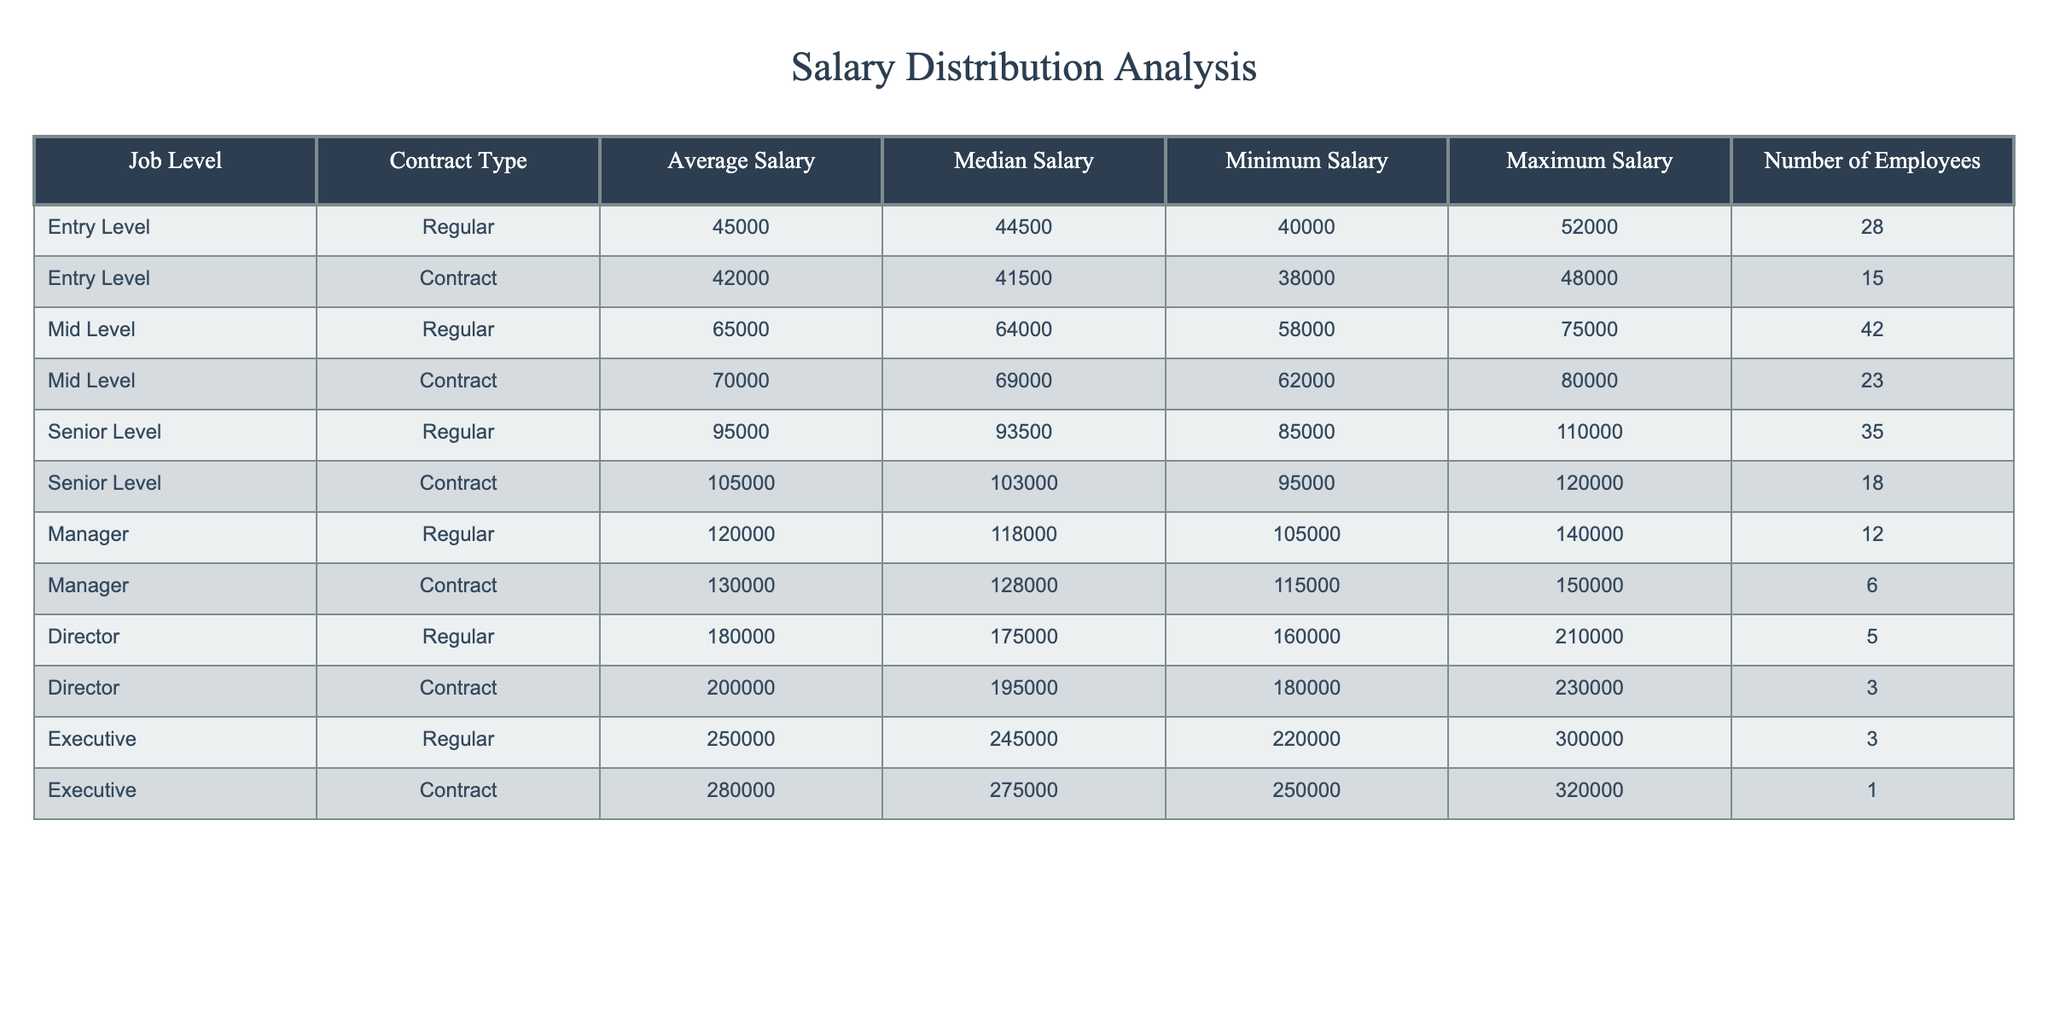What is the average salary for Senior Level Regular employees? The average salary for Senior Level Regular employees is listed in the table under the "Average Salary" column for that job level. It states 95000.
Answer: 95000 What is the median salary for Mid Level Contract workers? The median salary for Mid Level Contract workers can be found in the "Median Salary" column specifically for the Mid Level and Contract type, which is 69000.
Answer: 69000 Which job level has the highest minimum salary among Regular employees? By looking at the "Minimum Salary" column for Regular employees, we can see the minimum salaries are 40000 (Entry Level), 58000 (Mid Level), 85000 (Senior Level), 105000 (Manager), 160000 (Director), and 220000 (Executive). The highest minimum salary is 160000 for Director level.
Answer: 160000 Is the average salary for Contract workers generally higher than for Regular employees at the Mid Level? Comparing the average salaries for Mid Level Regular (65000) and Mid Level Contract (70000), the average salary for Mid Level Contract workers is indeed higher (70000 > 65000).
Answer: Yes What is the difference between the maximum salaries of Entry Level Regular and Contract employees? The maximum salary for Entry Level Regular employees is 52000 and for Entry Level Contract employees is 48000. The difference is calculated by subtracting the maximum of Contract from Regular: 52000 - 48000 = 4000.
Answer: 4000 At which job level and contract type do we see the largest salary range? To find this, we calculate the range (Maximum - Minimum) for each job level. For Contract employees: Entry (48000-38000=10000), Mid (80000-62000=18000), Senior (120000-95000=25000), Manager (150000-115000=35000), Director (230000-180000=50000), Executive (320000-250000=70000). The largest range is for Executive Contract employees, with a range of 70000.
Answer: Executive Contract How many employees are there in total for Regular Director and Contract Director levels? From the table, the number of employees is listed as 5 for Regular Director and 3 for Contract Director. The total is 5 + 3 = 8.
Answer: 8 Do more than half of the Senior Level employees work on a Contract basis? We find the total number of Senior Level employees: 35 Regular and 18 Contract, totaling 53. The number on Contract (18) is less than half of 53.
Answer: No What is the total number of employees for each Contract type? The total for Contract employees is calculated by summing 15 (Entry) + 23 (Mid) + 18 (Senior) + 6 (Manager) + 3 (Director) + 1 (Executive) = 66.
Answer: 66 What is the average salary of all Executive employees, combining both Regular and Contract types? The average salaries are 250000 for Regular and 280000 for Contract. To find the average of these two: (250000 + 280000) / 2 = 265000.
Answer: 265000 